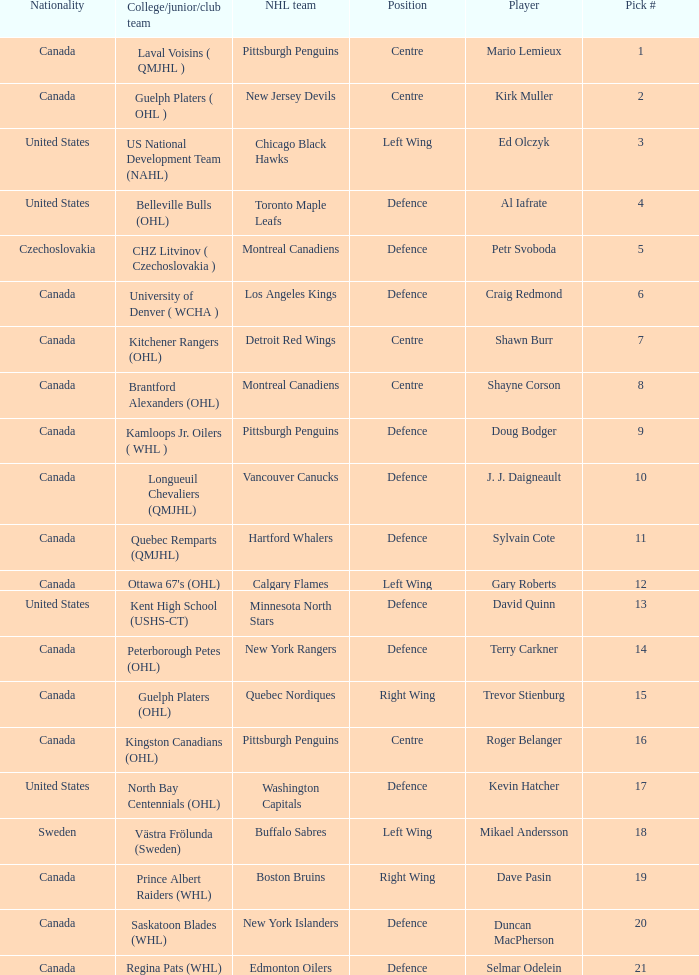Write the full table. {'header': ['Nationality', 'College/junior/club team', 'NHL team', 'Position', 'Player', 'Pick #'], 'rows': [['Canada', 'Laval Voisins ( QMJHL )', 'Pittsburgh Penguins', 'Centre', 'Mario Lemieux', '1'], ['Canada', 'Guelph Platers ( OHL )', 'New Jersey Devils', 'Centre', 'Kirk Muller', '2'], ['United States', 'US National Development Team (NAHL)', 'Chicago Black Hawks', 'Left Wing', 'Ed Olczyk', '3'], ['United States', 'Belleville Bulls (OHL)', 'Toronto Maple Leafs', 'Defence', 'Al Iafrate', '4'], ['Czechoslovakia', 'CHZ Litvinov ( Czechoslovakia )', 'Montreal Canadiens', 'Defence', 'Petr Svoboda', '5'], ['Canada', 'University of Denver ( WCHA )', 'Los Angeles Kings', 'Defence', 'Craig Redmond', '6'], ['Canada', 'Kitchener Rangers (OHL)', 'Detroit Red Wings', 'Centre', 'Shawn Burr', '7'], ['Canada', 'Brantford Alexanders (OHL)', 'Montreal Canadiens', 'Centre', 'Shayne Corson', '8'], ['Canada', 'Kamloops Jr. Oilers ( WHL )', 'Pittsburgh Penguins', 'Defence', 'Doug Bodger', '9'], ['Canada', 'Longueuil Chevaliers (QMJHL)', 'Vancouver Canucks', 'Defence', 'J. J. Daigneault', '10'], ['Canada', 'Quebec Remparts (QMJHL)', 'Hartford Whalers', 'Defence', 'Sylvain Cote', '11'], ['Canada', "Ottawa 67's (OHL)", 'Calgary Flames', 'Left Wing', 'Gary Roberts', '12'], ['United States', 'Kent High School (USHS-CT)', 'Minnesota North Stars', 'Defence', 'David Quinn', '13'], ['Canada', 'Peterborough Petes (OHL)', 'New York Rangers', 'Defence', 'Terry Carkner', '14'], ['Canada', 'Guelph Platers (OHL)', 'Quebec Nordiques', 'Right Wing', 'Trevor Stienburg', '15'], ['Canada', 'Kingston Canadians (OHL)', 'Pittsburgh Penguins', 'Centre', 'Roger Belanger', '16'], ['United States', 'North Bay Centennials (OHL)', 'Washington Capitals', 'Defence', 'Kevin Hatcher', '17'], ['Sweden', 'Västra Frölunda (Sweden)', 'Buffalo Sabres', 'Left Wing', 'Mikael Andersson', '18'], ['Canada', 'Prince Albert Raiders (WHL)', 'Boston Bruins', 'Right Wing', 'Dave Pasin', '19'], ['Canada', 'Saskatoon Blades (WHL)', 'New York Islanders', 'Defence', 'Duncan MacPherson', '20'], ['Canada', 'Regina Pats (WHL)', 'Edmonton Oilers', 'Defence', 'Selmar Odelein', '21']]} What nationality is the draft pick player going to Minnesota North Stars? United States. 